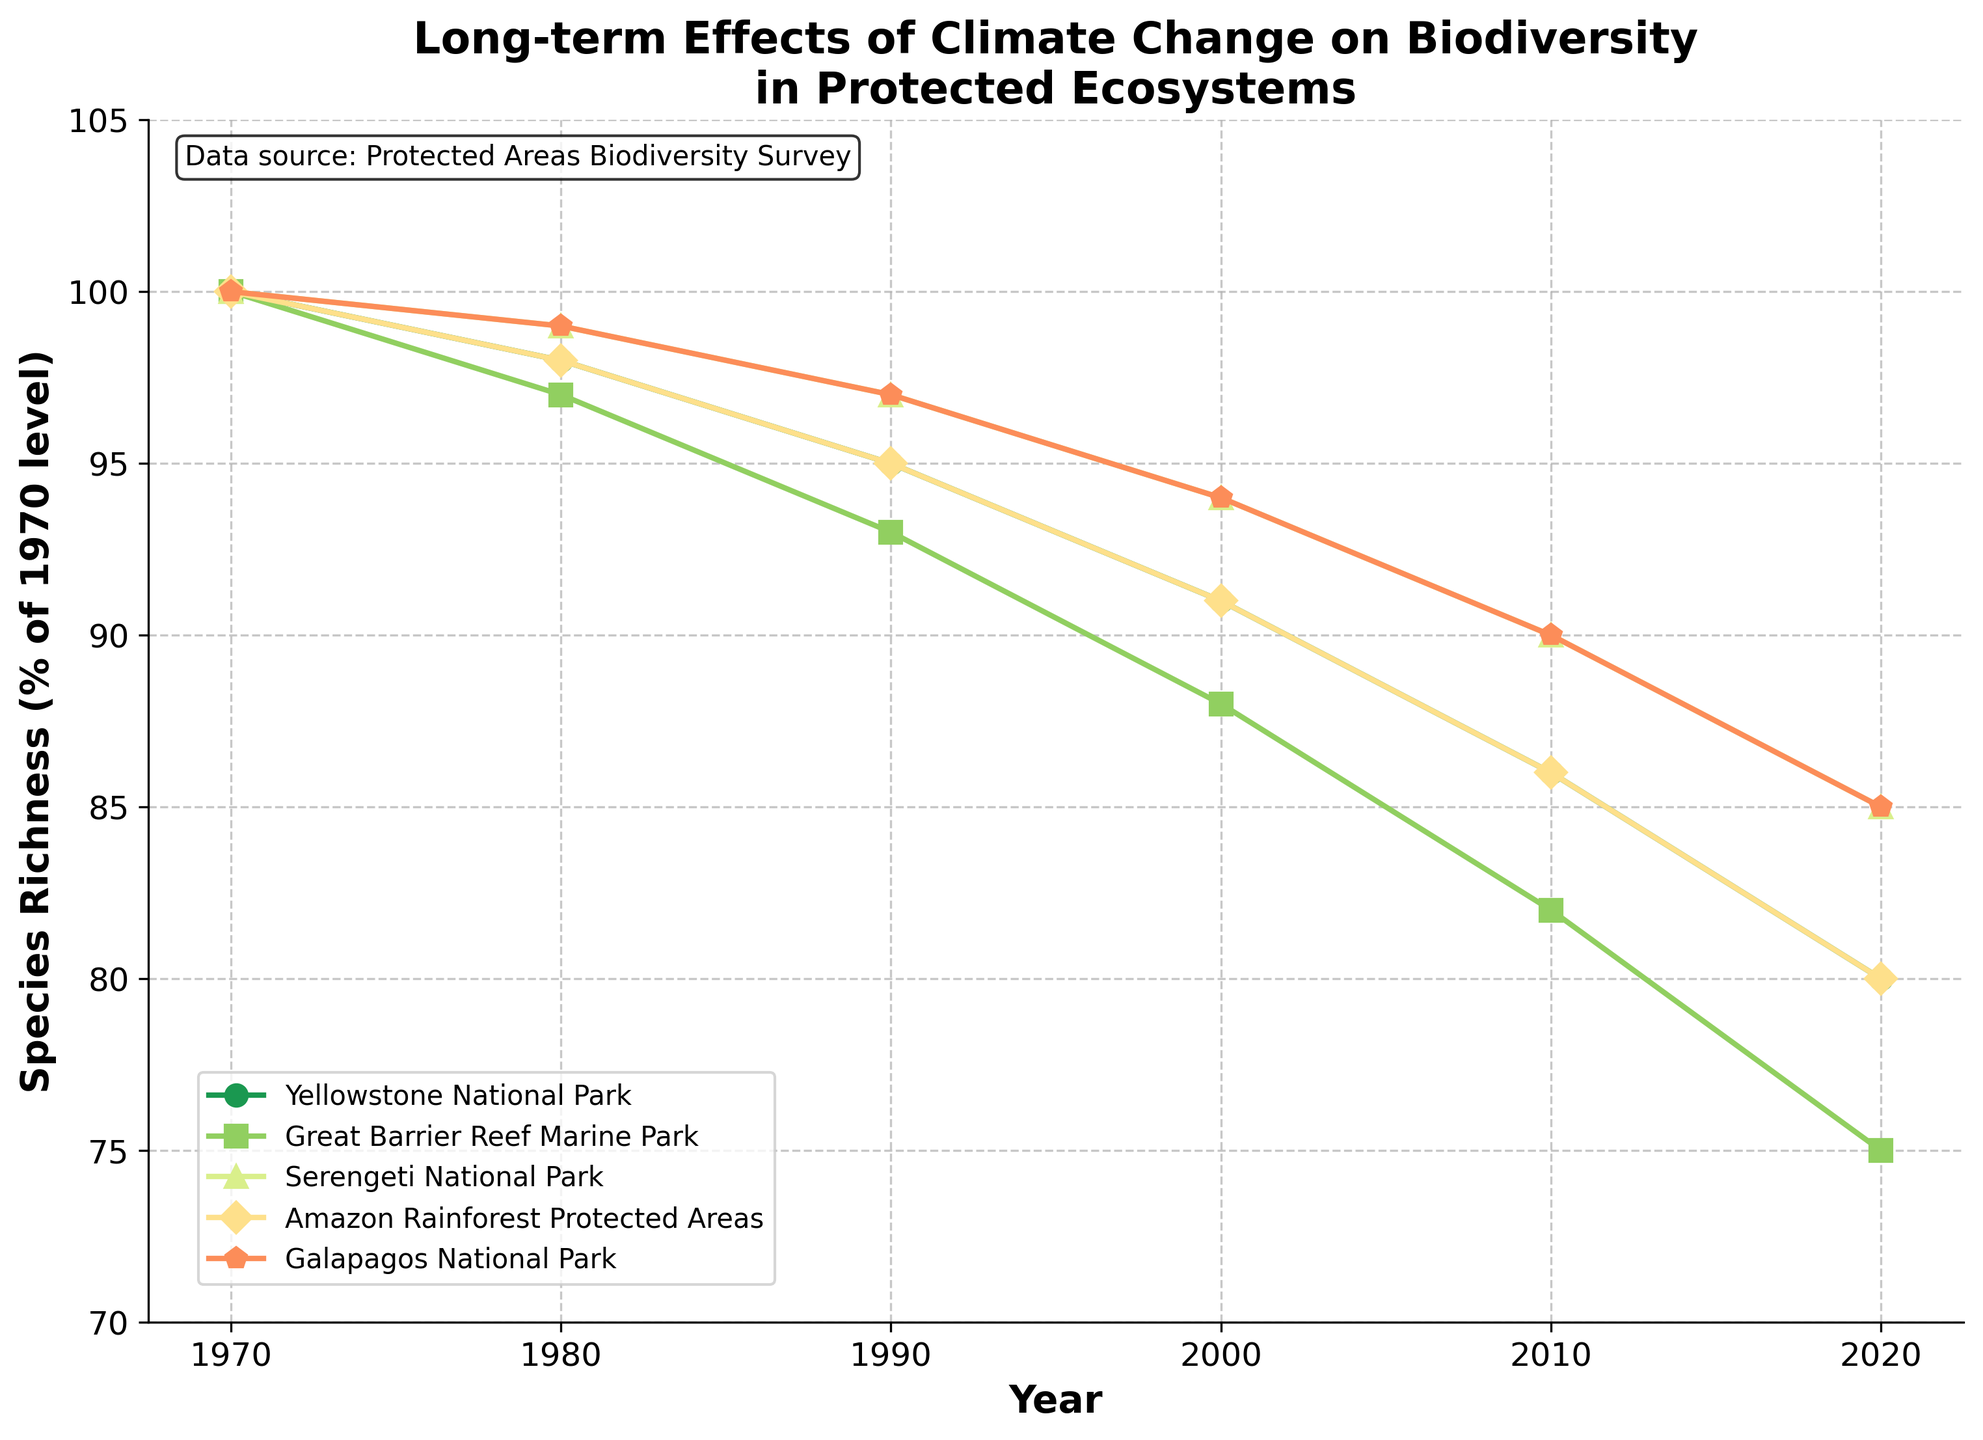How has species richness in Yellowstone National Park changed from 1970 to 2020? Look at the line for Yellowstone National Park from 1970 to 2020. Note the percentage values at 1970 (100%) and 2020 (80%). Calculate the change: 100% - 80% = 20%. This indicates a decrease of 20% in species richness.
Answer: Decreased by 20% Which park had the steepest decline in species richness over the 50-year period? Compare the slopes of the lines for all parks from 1970 to 2020. The steepest decline appears to be in the Great Barrier Reef Marine Park, which decreased from 100% in 1970 to 75% in 2020.
Answer: Great Barrier Reef Marine Park By how many percentage points did species richness in the Amazon Rainforest Protected Areas decrease from 1970 to 2000? Check the line for Amazon Rainforest Protected Areas. In 1970, species richness was at 100%, and in 2000, it was at 91%. Calculate the decrease: 100% - 91% = 9 percentage points.
Answer: 9 percentage points What was the average species richness in 2020 across all parks? Add the species richness values for all parks in 2020 and divide by the number of parks: (80 + 75 + 85 + 80 + 85) / 5 = 405 / 5 = 81%.
Answer: 81% Which park maintained the highest percentage of its species richness in 2020 relative to 1970 levels? Look for the line that stays highest in 2020. The Serengeti National Park and Galapagos National Park both end at 85%, which are the highest values for 2020.
Answer: Serengeti National Park and Galapagos National Park Between 1990 and 2000, which park had the smallest reduction in species richness? Compare the changes in species richness between 1990 and 2000 for each park. The smallest reduction is seen in the Galapagos National Park, going from 97% to 94%, a reduction of 3 percentage points.
Answer: Galapagos National Park What were the species richness values in 1980 for the Yellowstone National Park and Great Barrier Reef Marine Park, and what is the difference between them? Note the 1980 values for Yellowstone National Park (98%) and Great Barrier Reef Marine Park (97%). Calculate the difference: 98% - 97% = 1%.
Answer: 1% Which park shows the most stable trend in species richness over the 50-year period? Identify the line with the least sharp changes and consistent decline. The Serengeti National Park line shows a steady and gradual decline, indicating a more stable trend.
Answer: Serengeti National Park How much did species richness in the Galapagos National Park change between 1990 and 2010? Identify the Galapagos National Park values for 1990 (97%) and 2010 (90%). Calculate the change: 97% - 90% = 7%.
Answer: 7% How does the species richness in the Great Barrier Reef Marine Park in 2020 compare to its species richness in 1980? Look at the Great Barrier Reef Marine Park values for 2020 (75%) and 1980 (97%). The difference is 97% - 75% = 22%. This indicates a 22% decrease.
Answer: Decreased by 22% 